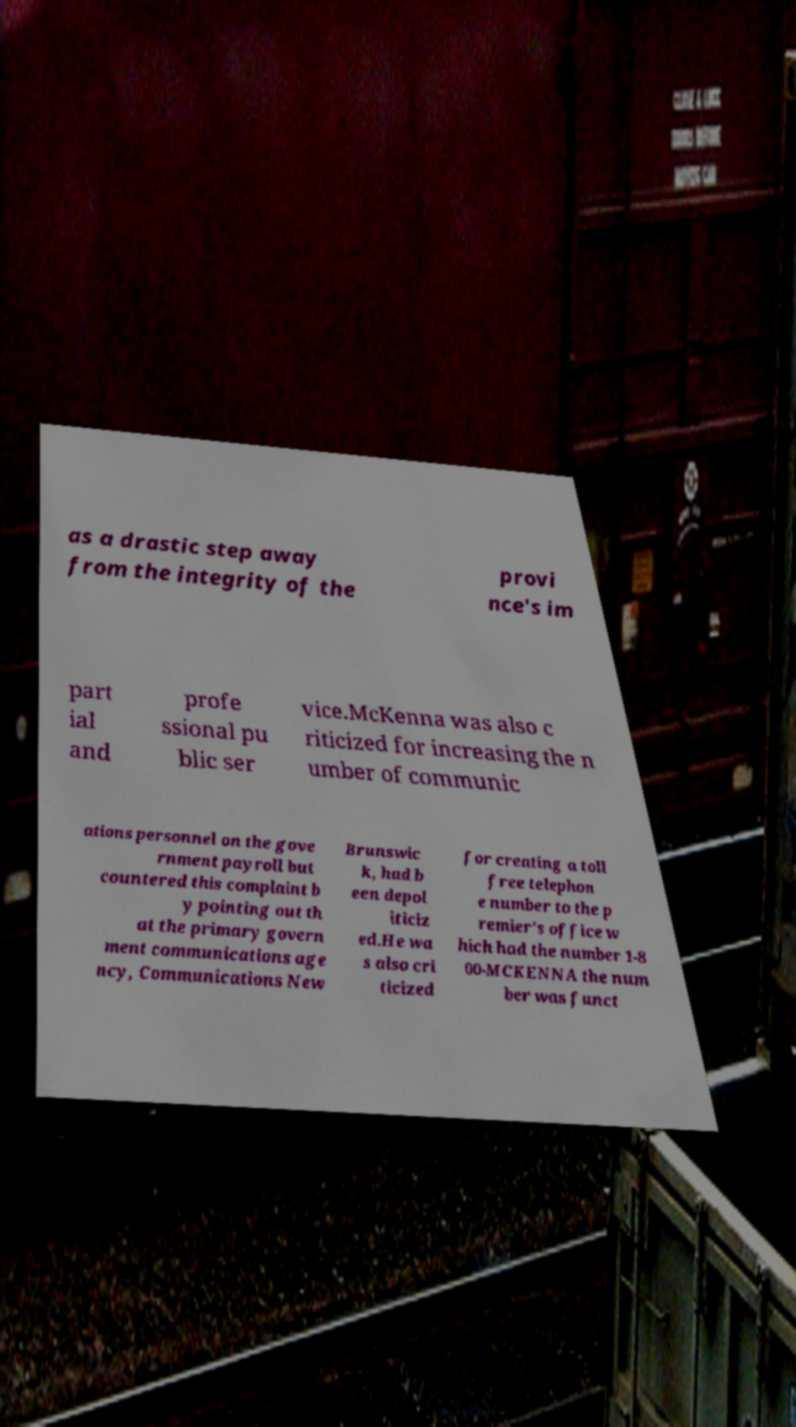I need the written content from this picture converted into text. Can you do that? as a drastic step away from the integrity of the provi nce's im part ial and profe ssional pu blic ser vice.McKenna was also c riticized for increasing the n umber of communic ations personnel on the gove rnment payroll but countered this complaint b y pointing out th at the primary govern ment communications age ncy, Communications New Brunswic k, had b een depol iticiz ed.He wa s also cri ticized for creating a toll free telephon e number to the p remier's office w hich had the number 1-8 00-MCKENNA the num ber was funct 